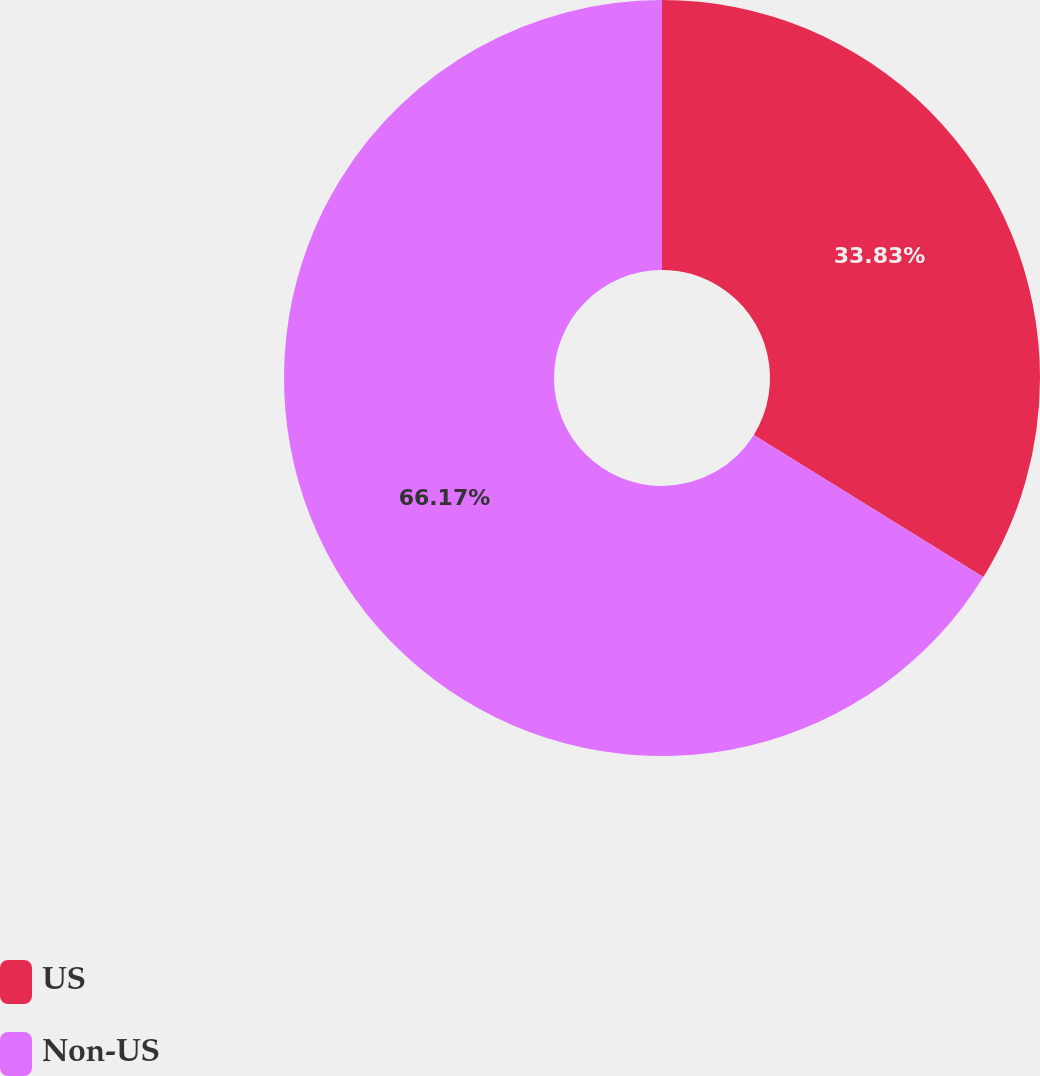Convert chart to OTSL. <chart><loc_0><loc_0><loc_500><loc_500><pie_chart><fcel>US<fcel>Non-US<nl><fcel>33.83%<fcel>66.17%<nl></chart> 